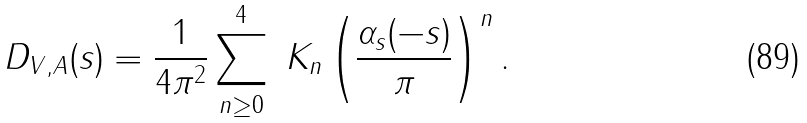<formula> <loc_0><loc_0><loc_500><loc_500>D _ { V , A } ( s ) = \frac { 1 } { 4 \pi ^ { 2 } } \sum _ { n \geq 0 } ^ { 4 } \ K _ { n } \left ( \frac { \alpha _ { s } ( - s ) } { \pi } \right ) ^ { n } .</formula> 